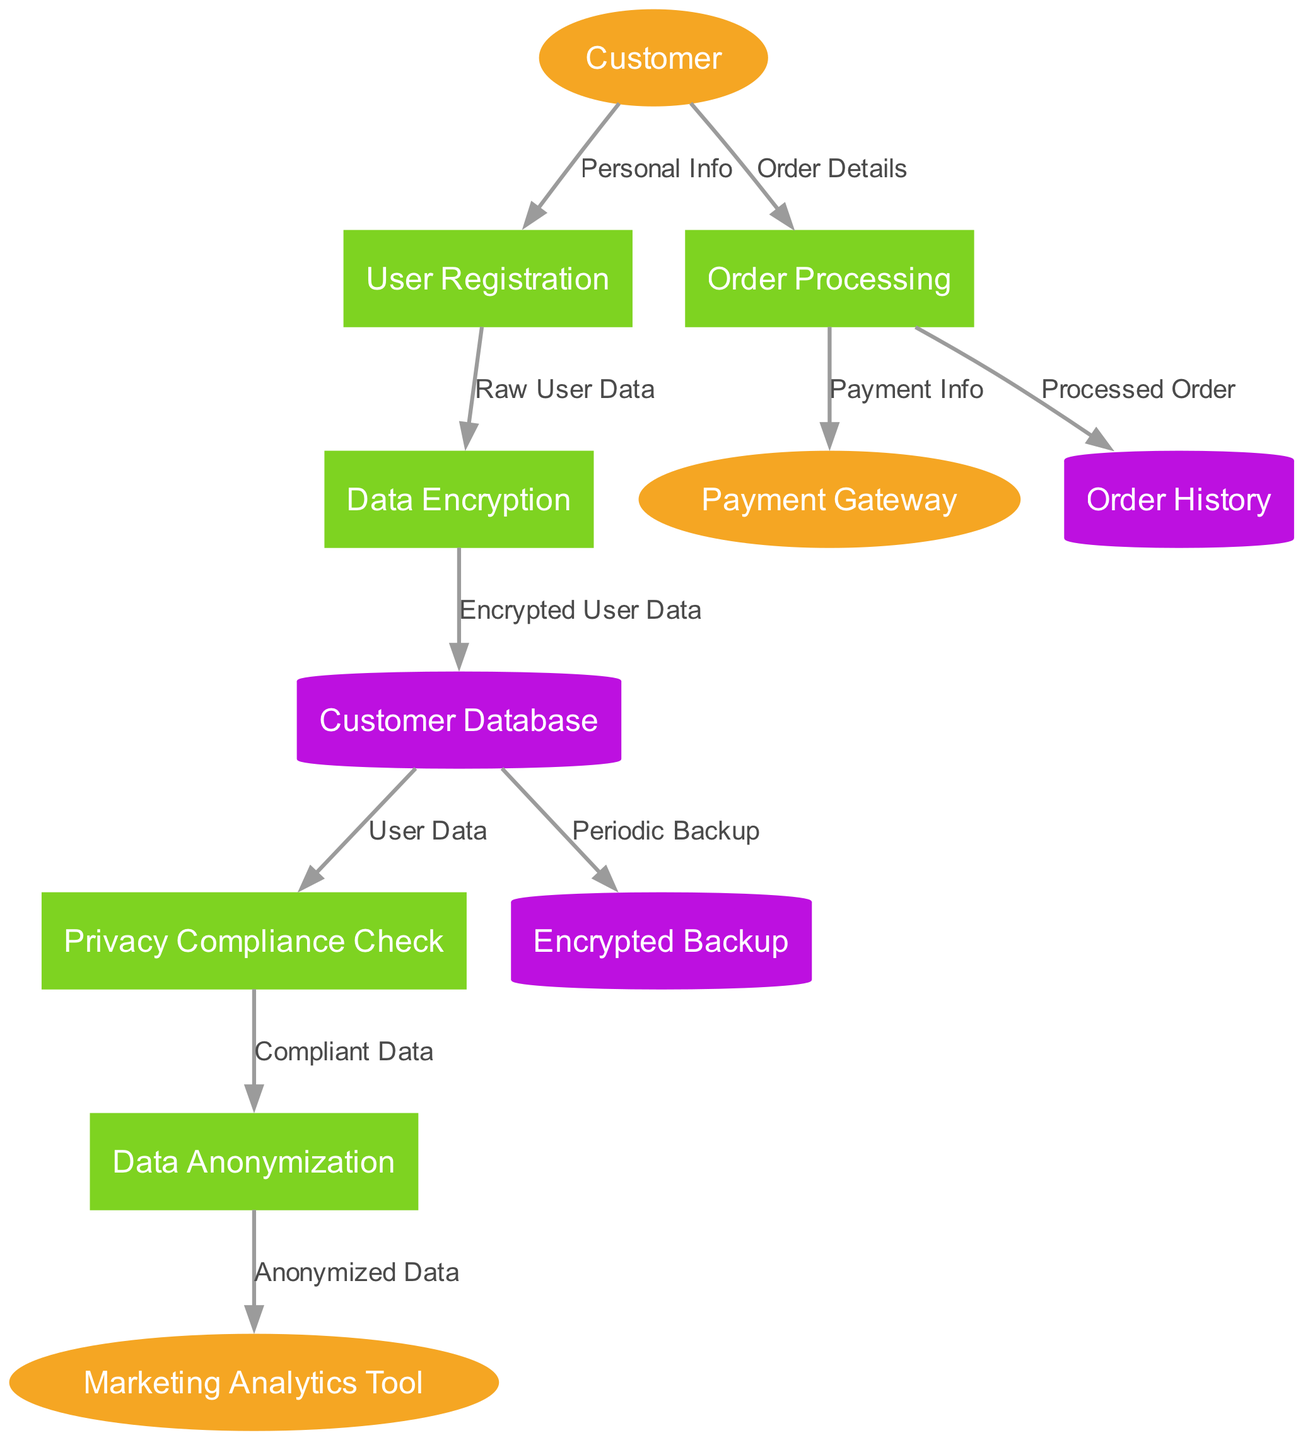What is the first process in the data flow? The first process in the data flow is identified as "User Registration," which is the initial step that receives data from the customer.
Answer: User Registration How many external entities are there in the diagram? The diagram includes three external entities: Customer, Payment Gateway, and Marketing Analytics Tool. Counting these entities gives us the total.
Answer: 3 What does the Customer send to the Order Processing? The Customer sends "Order Details" to the Order Processing process as indicated in the data flow.
Answer: Order Details Which process uses "Compliant Data"? The "Privacy Compliance Check" process uses "Compliant Data," which it receives from the Customer Database before passing it to the Data Anonymization process.
Answer: Privacy Compliance Check How is "Encrypted User Data" stored? "Encrypted User Data" is stored in the "Customer Database" after being processed by "Data Encryption," which indicates that this data is safely kept in the associated data store.
Answer: Customer Database What happens to user data after Data Encryption? After Data Encryption, the data is sent to the Customer Database as "Encrypted User Data," indicating storage of securely encrypted information.
Answer: Customer Database Which data store receives "Periodic Backup"? The "Customer Database" is the data store that receives "Periodic Backup," showing that it is backed up regularly for data security and recovery purposes.
Answer: Encrypted Backup What type of data is sent to the Marketing Analytics Tool? The "Anonymized Data" is sent to the Marketing Analytics Tool after being processed through Data Anonymization, ensuring it is de-identified for analysis.
Answer: Anonymized Data Which process comes directly after Order Processing? The process that comes directly after Order Processing is the "Payment Gateway," which receives "Payment Info" from the Order Processing step.
Answer: Payment Gateway 